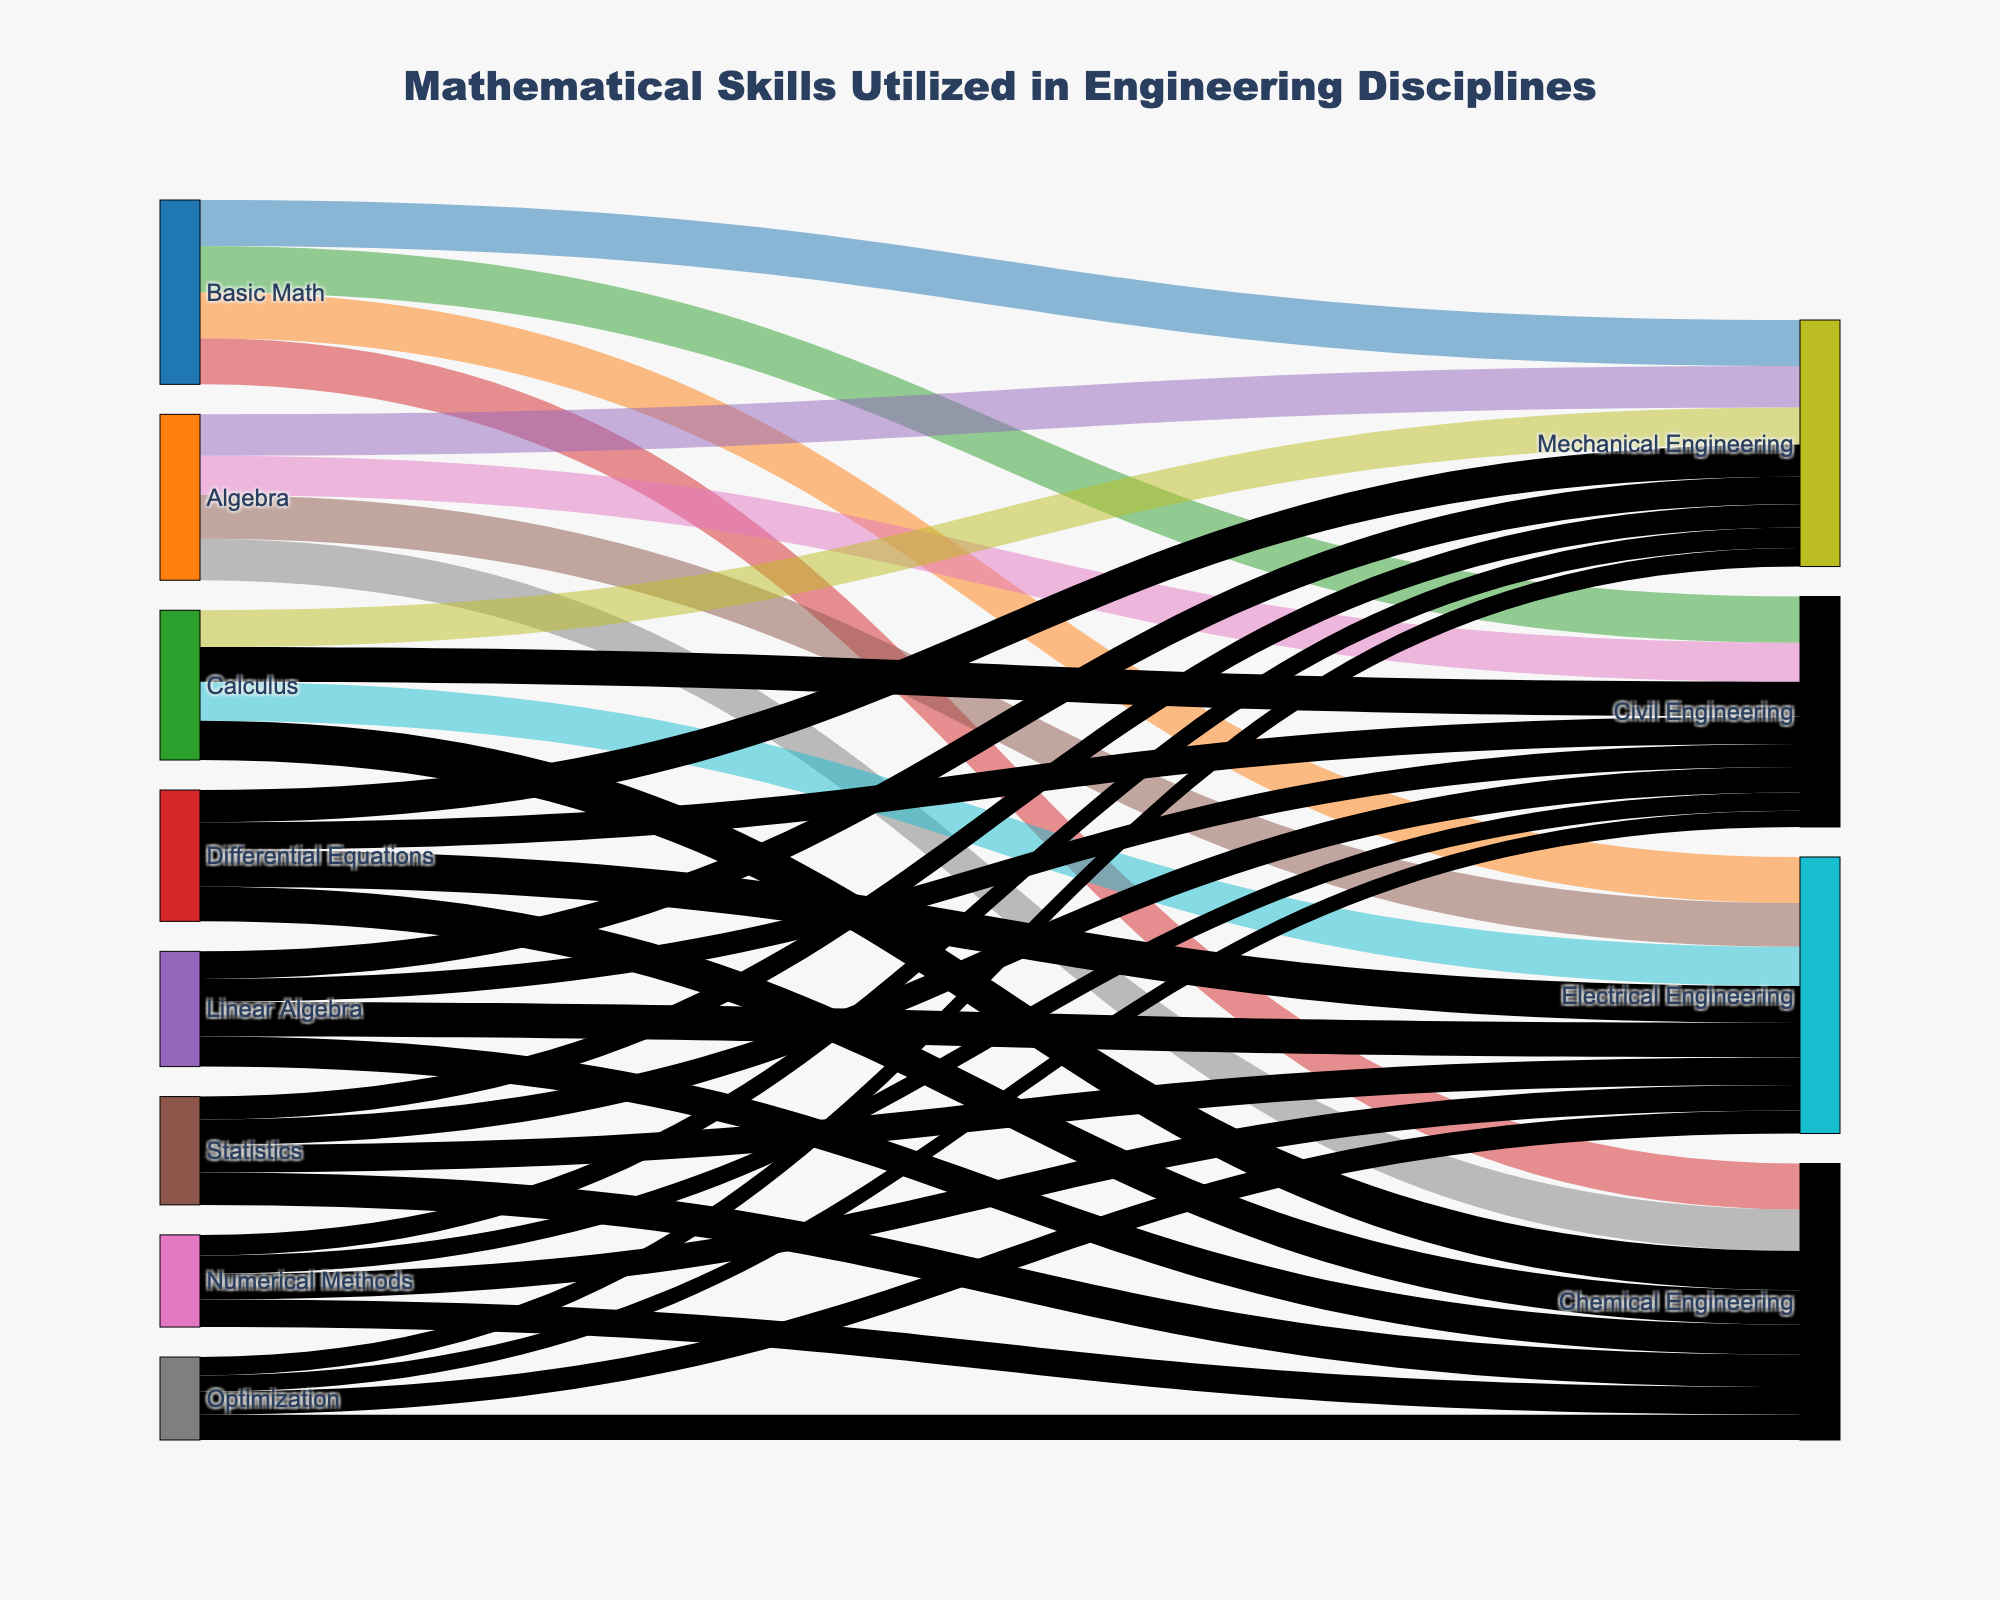What is the title of the Sankey diagram? The title of the Sankey diagram can be found at the top of the figure in a larger or bold font.
Answer: Mathematical Skills Utilized in Engineering Disciplines Which engineering discipline has the lowest utilization of Optimization skills? By observing the width of the links flowing into each engineering discipline from 'Optimization', the thinnest link represents the lowest utilization.
Answer: Civil Engineering How many disciplines utilize Differential Equations more than 70 units? Check the thickness of the links originating from 'Differential Equations'. Links thicker than 70 units indicate utilization greater than 70 units. Count these links.
Answer: 3 What is the total utilization value of Algebra skills across all engineering disciplines? Sum the values of all links originating from 'Algebra' to each of the engineering disciplines.
Answer: 360 Which mathematical skill has the highest utilization in Electrical Engineering? Compare the widths of the links flowing into 'Electrical Engineering' from each mathematical skill. The link with the greatest width represents the highest utilization.
Answer: Algebra What is the average utilization of Statistics skills across all engineering disciplines? Sum the utilization values of 'Statistics' for each discipline and divide by the number of disciplines. \((50 + 60 + 55 + 70) / 4 = 235 / 4\)
Answer: 58.75 Between Mechanical Engineering and Chemical Engineering, which has a greater utilization of Calculus skills, and by how much? Compare the values of Calculus skills utilized in both disciplines. The difference between these values gives the answer. \((85 - 80)\)
Answer: Chemical Engineering by 5 units How does the utilization of Linear Algebra in Civil Engineering compare to Mechanical Engineering? Compare the value of the link from 'Linear Algebra' to 'Civil Engineering' with that to 'Mechanical Engineering'.
Answer: 50 units (Civil Engineering) is less than 60 units (Mechanical Engineering) What is the total number of unique mathematical skills represented in the diagram? Count the unique mathematical skills listed as sources in the diagram.
Answer: 8 Which engineering discipline exhibits the most diverse utilization across all mathematical skills? Identify the engineering discipline with the widest range of link thicknesses, suggesting varied utilization across different mathematical skills.
Answer: Electrical Engineering 